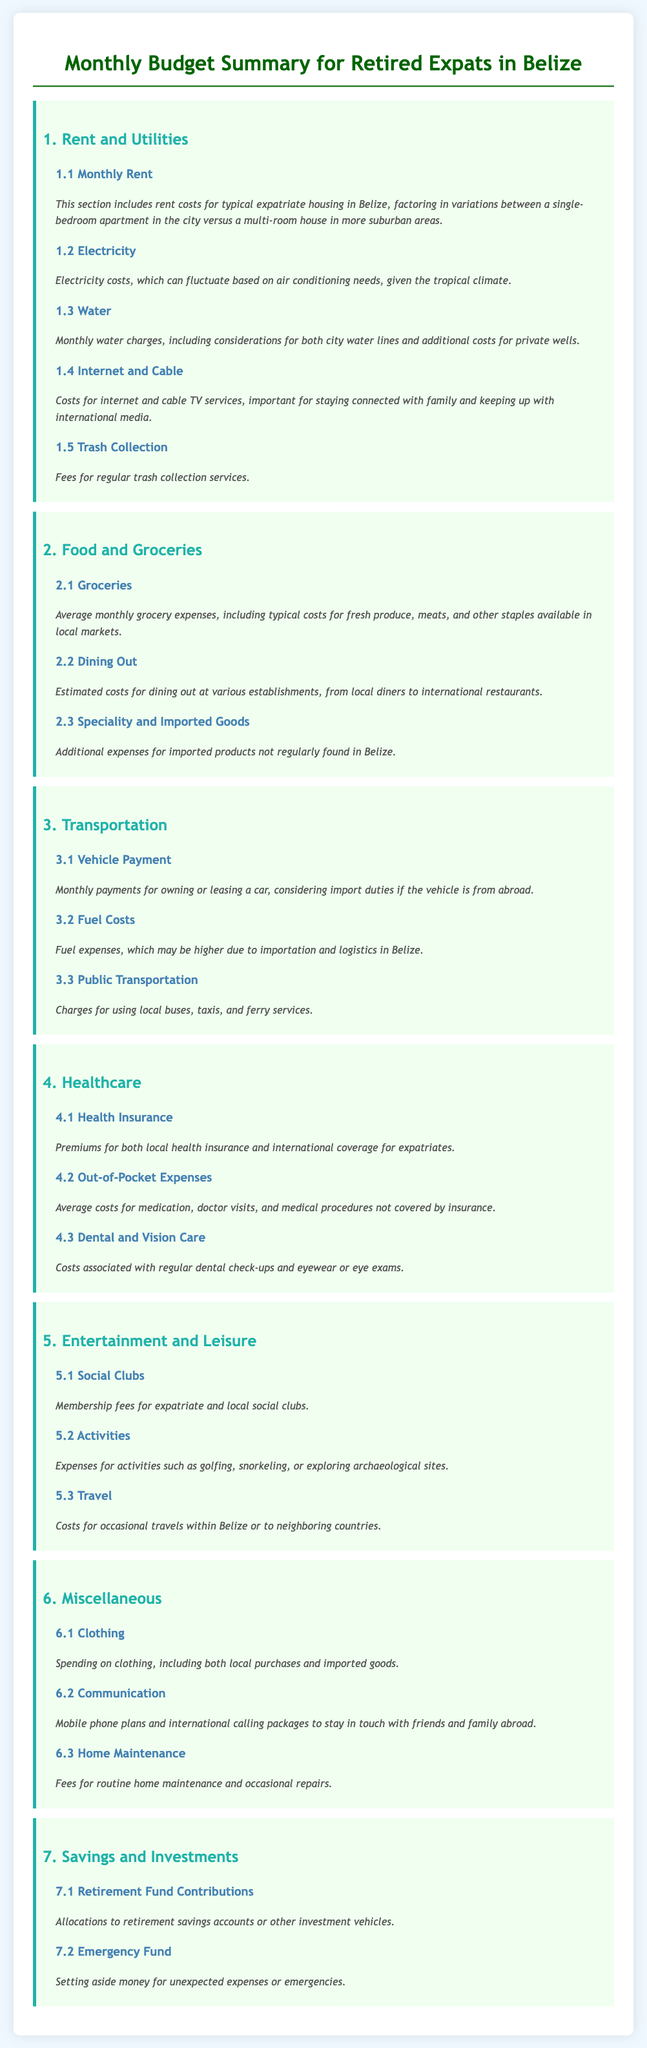What are the categories listed in the budget summary? The categories listed in the budget summary include Rent and Utilities, Food and Groceries, Transportation, Healthcare, Entertainment and Leisure, Miscellaneous, and Savings and Investments.
Answer: Rent and Utilities, Food and Groceries, Transportation, Healthcare, Entertainment and Leisure, Miscellaneous, Savings and Investments What is included in Monthly Rent? Monthly Rent includes rent costs for typical expatriate housing in Belize, factoring in variations between a single-bedroom apartment in the city versus a multi-room house in more suburban areas.
Answer: Rent costs for typical expatriate housing How many subcategories are in the Healthcare category? The Healthcare category has three subcategories: Health Insurance, Out-of-Pocket Expenses, and Dental and Vision Care.
Answer: Three What is the average spending on groceries? The average spending on groceries includes typical costs for fresh produce, meats, and other staples available in local markets.
Answer: Typical costs for fresh produce, meats, and other staples What are the average costs for fuel? Fuel costs may be higher due to importation and logistics in Belize.
Answer: Higher Which category covers Membership fees? Membership fees for expatriate and local social clubs are covered in the Entertainment and Leisure category.
Answer: Entertainment and Leisure What types of expenses are considered Miscellaneous? Miscellaneous expenses include Clothing, Communication, and Home Maintenance.
Answer: Clothing, Communication, Home Maintenance How are retirement funds categorized in the budget summary? Retirement funds are categorized as contributions to retirement savings accounts or other investment vehicles.
Answer: Contributions to retirement savings accounts 